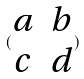Convert formula to latex. <formula><loc_0><loc_0><loc_500><loc_500>( \begin{matrix} a & b \\ c & d \end{matrix} )</formula> 